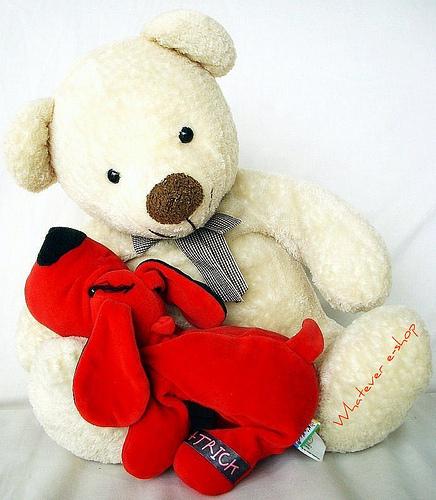Are these animals or toys?
Keep it brief. Toys. What color is the dog?
Write a very short answer. Red. What is the bear holding?
Answer briefly. Dog. 